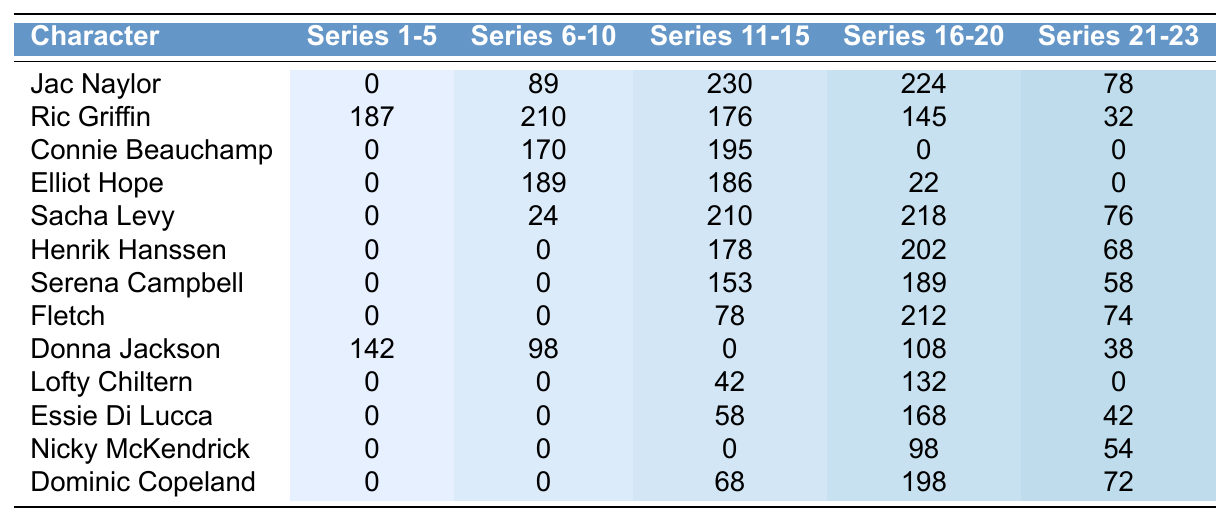What character appeared the most in Series 11-15? Looking at the values in Series 11-15, Jac Naylor has 230 appearances, which is the highest among all characters listed.
Answer: Jac Naylor How many total appearances did Ric Griffin have across all series? To find Ric Griffin's total appearances, we sum his appearances: 187 + 210 + 176 + 145 + 32 = 750.
Answer: 750 Did Connie Beauchamp appear in Series 1-5? Connie Beauchamp has 0 appearances listed for Series 1-5, indicating she did not appear during those seasons.
Answer: No Which two characters have the same number of appearances in Series 21-23? Fletch has 74 and Dominic Copeland has 72 appearances; they are close, but do not have the same number. Therefore, there are no characters with the same number of appearances in this series range.
Answer: No What is the average appearance count for Sacha Levy across all series? The total appearances for Sacha Levy are 0 + 24 + 210 + 218 + 76 = 528. There are 5 series, so the average is 528 / 5 = 105.6.
Answer: 105.6 Which character had the highest appearances between Series 16-20? Jac Naylor has 224 appearances, which is the highest in Series 16-20 compared to others listed.
Answer: Jac Naylor How many appearances did Donna Jackson make in Series 21-23? According to the table, Donna Jackson has 38 appearances in Series 21-23.
Answer: 38 What is the difference in appearances between Elliot Hope in Series 11-15 and 16-20? Elliot Hope had 186 appearances in Series 11-15 and 22 in Series 16-20, so the difference is 186 - 22 = 164.
Answer: 164 How many characters have more than 200 appearances in Series 11-15? In Series 11-15, Jac Naylor (230) and Sacha Levy (210) are the only characters with more than 200 appearances. Counting them gives us a total of 2 characters.
Answer: 2 Which character made the least appearances in Series 1-5? All characters appear to have either 0 or a certain number in Series 1-5. Here, Jac Naylor and several others, including Lofty Chiltern, have 0 appearances. Jac Naylor is the first listed, still meeting the condition for the least appearances.
Answer: Jac Naylor 